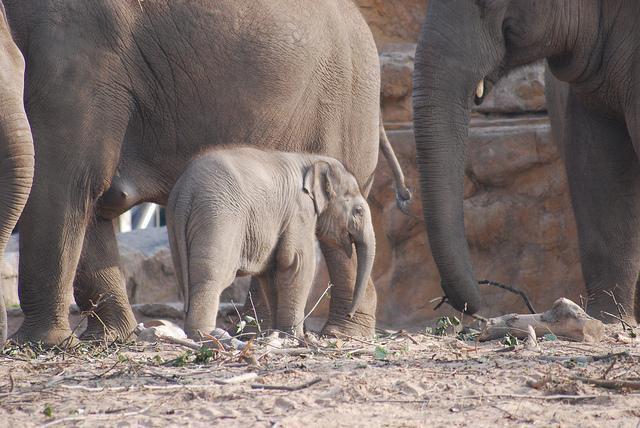How many baby animals in this picture?
Give a very brief answer. 1. How many elephants are there?
Give a very brief answer. 3. How many elephants are in the picture?
Give a very brief answer. 4. 